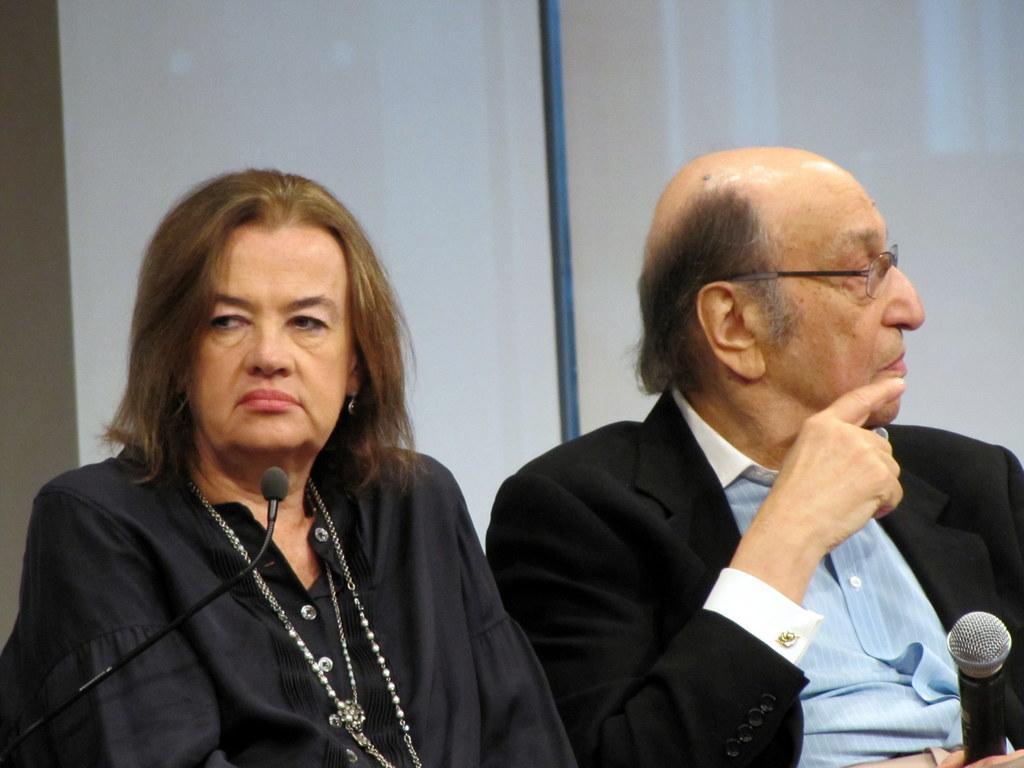Can you describe this image briefly? In this picture, I see a man and a woman seated and I see a man holding a microphone in his hand and on the left we see another microphone in front of the women and we see a projector light on the back of them. 